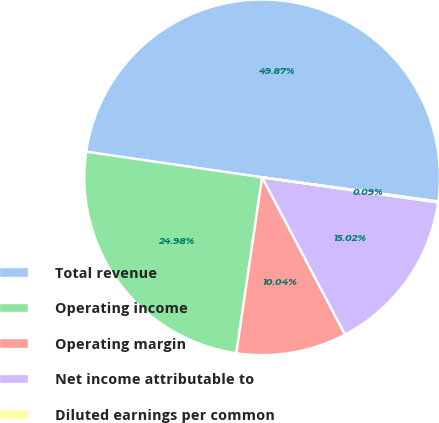<chart> <loc_0><loc_0><loc_500><loc_500><pie_chart><fcel>Total revenue<fcel>Operating income<fcel>Operating margin<fcel>Net income attributable to<fcel>Diluted earnings per common<nl><fcel>49.87%<fcel>24.98%<fcel>10.04%<fcel>15.02%<fcel>0.09%<nl></chart> 